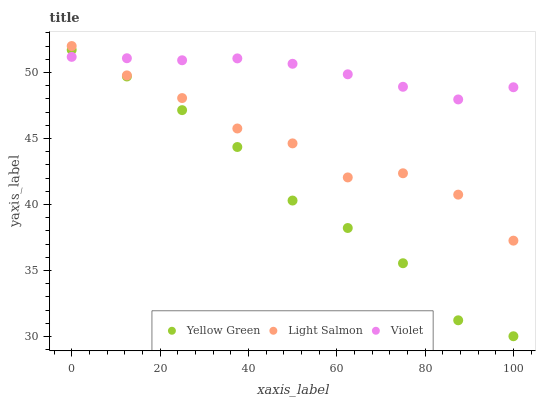Does Yellow Green have the minimum area under the curve?
Answer yes or no. Yes. Does Violet have the maximum area under the curve?
Answer yes or no. Yes. Does Violet have the minimum area under the curve?
Answer yes or no. No. Does Yellow Green have the maximum area under the curve?
Answer yes or no. No. Is Violet the smoothest?
Answer yes or no. Yes. Is Light Salmon the roughest?
Answer yes or no. Yes. Is Yellow Green the smoothest?
Answer yes or no. No. Is Yellow Green the roughest?
Answer yes or no. No. Does Yellow Green have the lowest value?
Answer yes or no. Yes. Does Violet have the lowest value?
Answer yes or no. No. Does Light Salmon have the highest value?
Answer yes or no. Yes. Does Yellow Green have the highest value?
Answer yes or no. No. Is Yellow Green less than Light Salmon?
Answer yes or no. Yes. Is Light Salmon greater than Yellow Green?
Answer yes or no. Yes. Does Yellow Green intersect Violet?
Answer yes or no. Yes. Is Yellow Green less than Violet?
Answer yes or no. No. Is Yellow Green greater than Violet?
Answer yes or no. No. Does Yellow Green intersect Light Salmon?
Answer yes or no. No. 